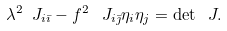Convert formula to latex. <formula><loc_0><loc_0><loc_500><loc_500>\lambda ^ { 2 } \ J _ { i \bar { \imath } } - f ^ { 2 } \, \ J _ { i \bar { \jmath } } \eta _ { i } \eta _ { j } = \det \ J .</formula> 